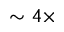<formula> <loc_0><loc_0><loc_500><loc_500>\sim 4 \times</formula> 